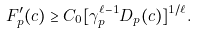Convert formula to latex. <formula><loc_0><loc_0><loc_500><loc_500>F ^ { \prime } _ { p } ( c ) \geq C _ { 0 } [ \gamma _ { p } ^ { \ell - 1 } D _ { p } ( c ) ] ^ { 1 / \ell } .</formula> 